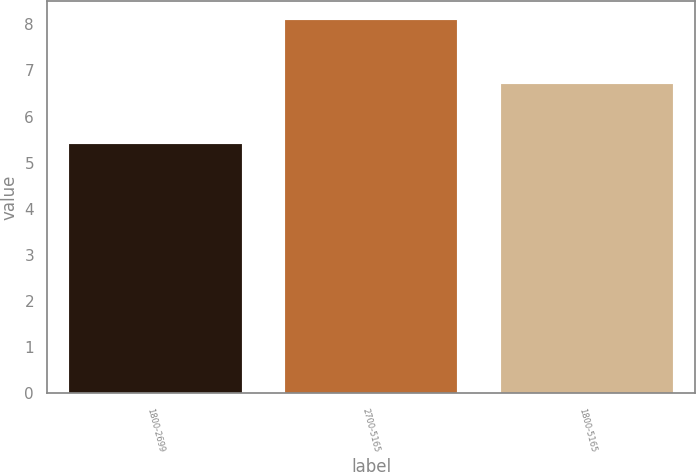Convert chart to OTSL. <chart><loc_0><loc_0><loc_500><loc_500><bar_chart><fcel>1800-2699<fcel>2700-5165<fcel>1800-5165<nl><fcel>5.4<fcel>8.1<fcel>6.7<nl></chart> 